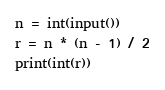Convert code to text. <code><loc_0><loc_0><loc_500><loc_500><_Python_>n = int(input())
r = n * (n - 1) / 2
print(int(r))
</code> 